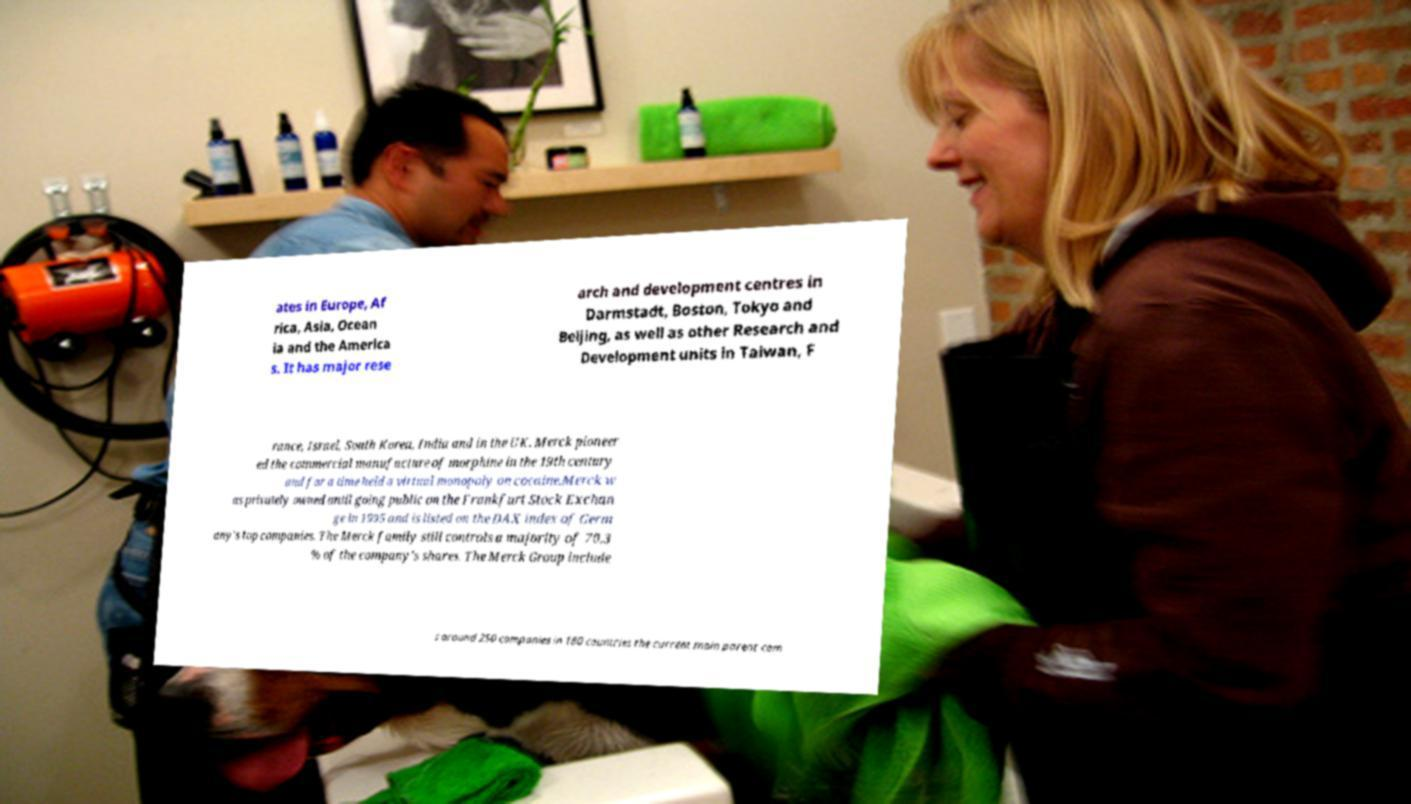I need the written content from this picture converted into text. Can you do that? ates in Europe, Af rica, Asia, Ocean ia and the America s. It has major rese arch and development centres in Darmstadt, Boston, Tokyo and Beijing, as well as other Research and Development units in Taiwan, F rance, Israel, South Korea, India and in the UK. Merck pioneer ed the commercial manufacture of morphine in the 19th century and for a time held a virtual monopoly on cocaine.Merck w as privately owned until going public on the Frankfurt Stock Exchan ge in 1995 and is listed on the DAX index of Germ any's top companies. The Merck family still controls a majority of 70.3 % of the company's shares. The Merck Group include s around 250 companies in 180 countries the current main parent com 